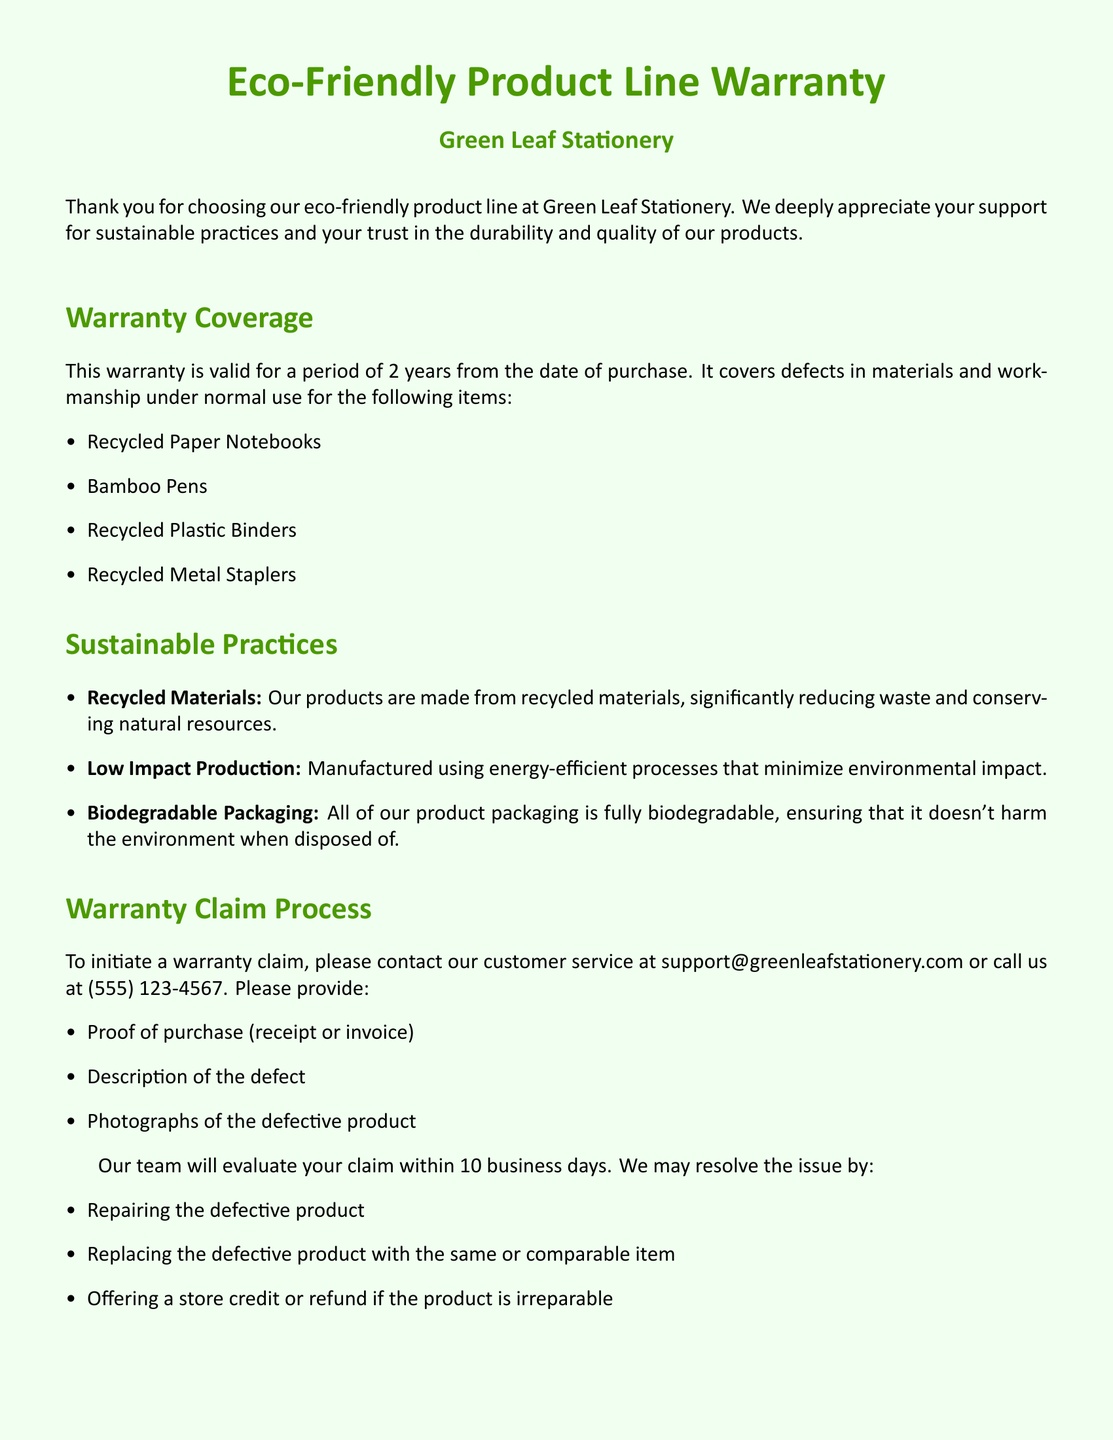What is the warranty period? The warranty covers defects in materials and workmanship for a period of 2 years from the date of purchase.
Answer: 2 years What products are covered under this warranty? The warranty covers specific products listed in the document under the warranty coverage section.
Answer: Recycled Paper Notebooks, Bamboo Pens, Recycled Plastic Binders, Recycled Metal Staplers How can customers initiate a warranty claim? Customers need to contact customer service via email or phone to start a warranty claim.
Answer: support@greenleafstationery.com or (555) 123-4567 What type of materials are used in the products? The document states that the products are made from materials that are beneficial for the environment.
Answer: Recycled materials How long will it take to evaluate a warranty claim? The document states a processing timeframe mentioned in the warranty claim process section.
Answer: 10 business days What does the warranty not cover? The exclusions section details the specific conditions under which the warranty is not applicable.
Answer: Normal wear and tear, misuse or abuse, accidental damage, modifications or repairs What type of packaging is used for the products? The document specifies the type of packaging used and its environmental impact.
Answer: Biodegradable packaging What might the company offer if a product is irreparable? The document outlines potential resolutions for claims including options if a product cannot be repaired.
Answer: Store credit or refund 